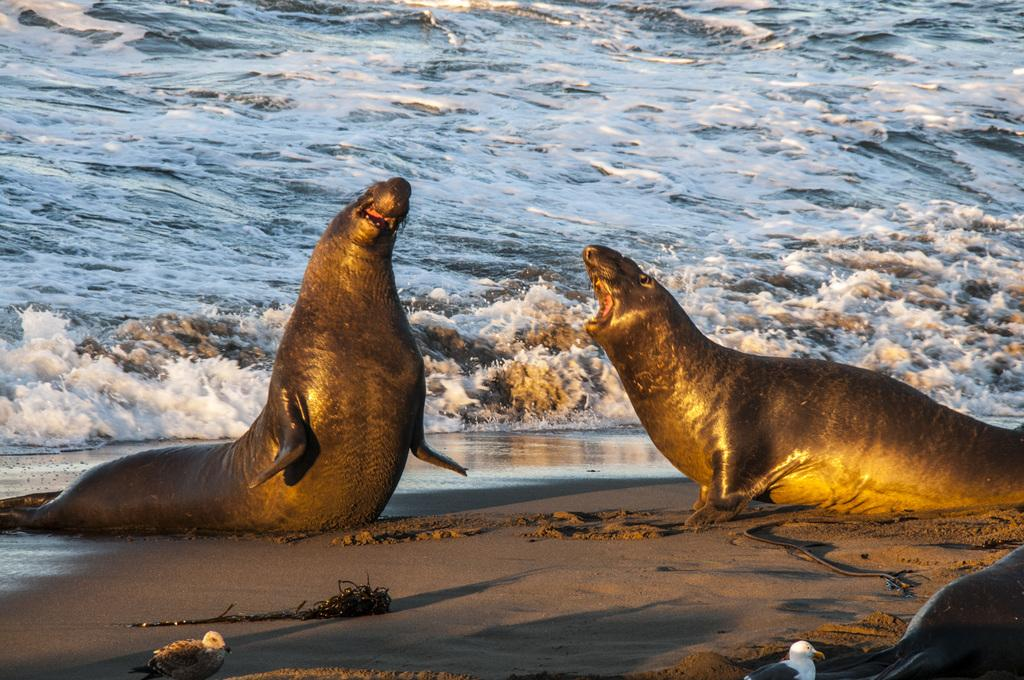What animals are present in the image? There are two seals in the image. What type of terrain is visible at the bottom of the image? There is sand at the bottom of the image. What other animals can be seen in the image besides the seals? There are two birds in the image. What type of location is depicted in the background of the image? There is a beach visible in the background of the image. What is the payment method for the seals in the image? There is no payment method mentioned or implied in the image, as it features seals and birds on a beach. 